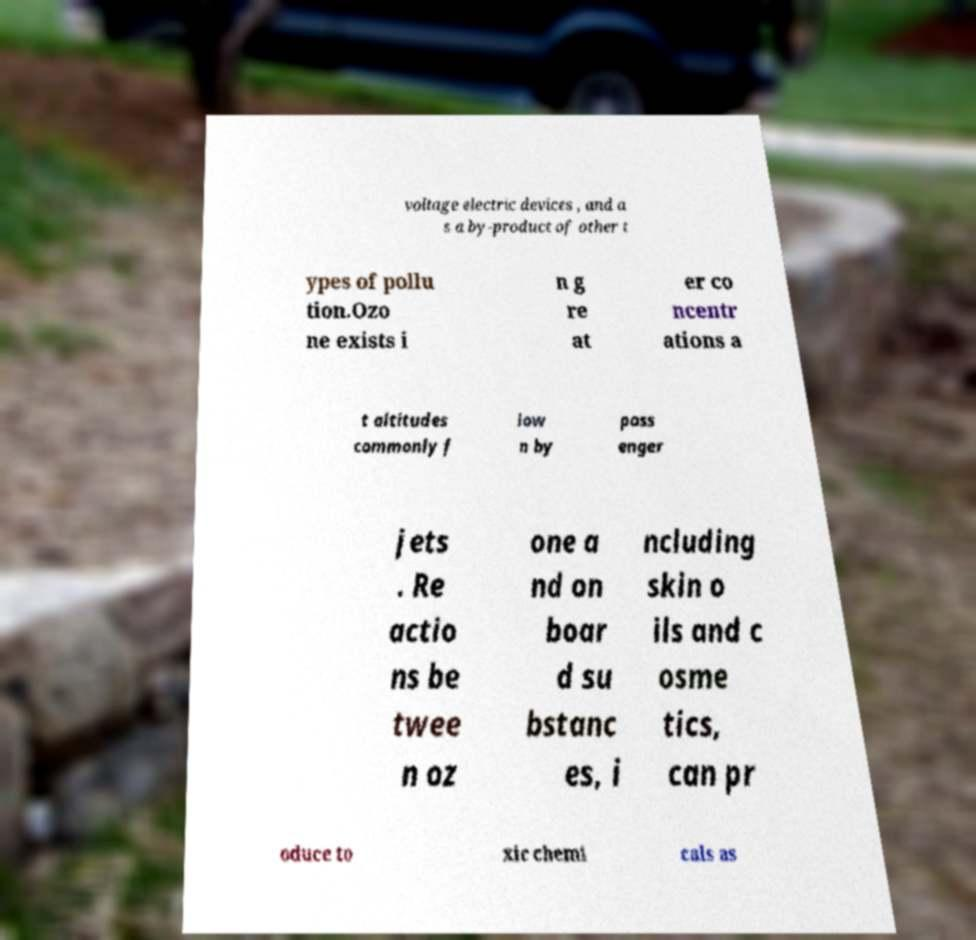Could you assist in decoding the text presented in this image and type it out clearly? voltage electric devices , and a s a by-product of other t ypes of pollu tion.Ozo ne exists i n g re at er co ncentr ations a t altitudes commonly f low n by pass enger jets . Re actio ns be twee n oz one a nd on boar d su bstanc es, i ncluding skin o ils and c osme tics, can pr oduce to xic chemi cals as 